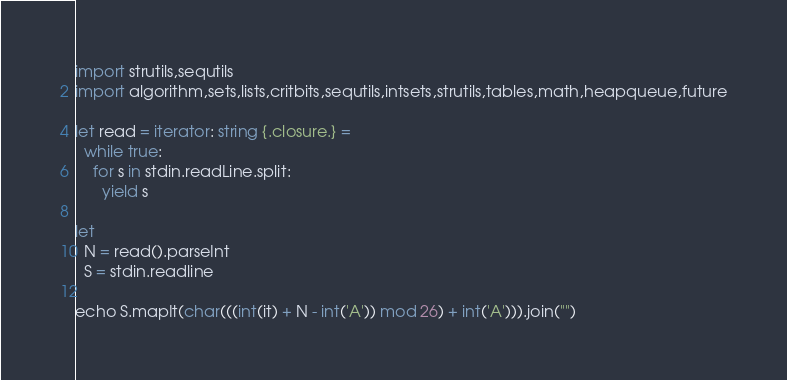<code> <loc_0><loc_0><loc_500><loc_500><_Nim_>import strutils,sequtils
import algorithm,sets,lists,critbits,sequtils,intsets,strutils,tables,math,heapqueue,future

let read = iterator: string {.closure.} =
  while true:
    for s in stdin.readLine.split:
      yield s

let
  N = read().parseInt
  S = stdin.readline

echo S.mapIt(char(((int(it) + N - int('A')) mod 26) + int('A'))).join("")
</code> 